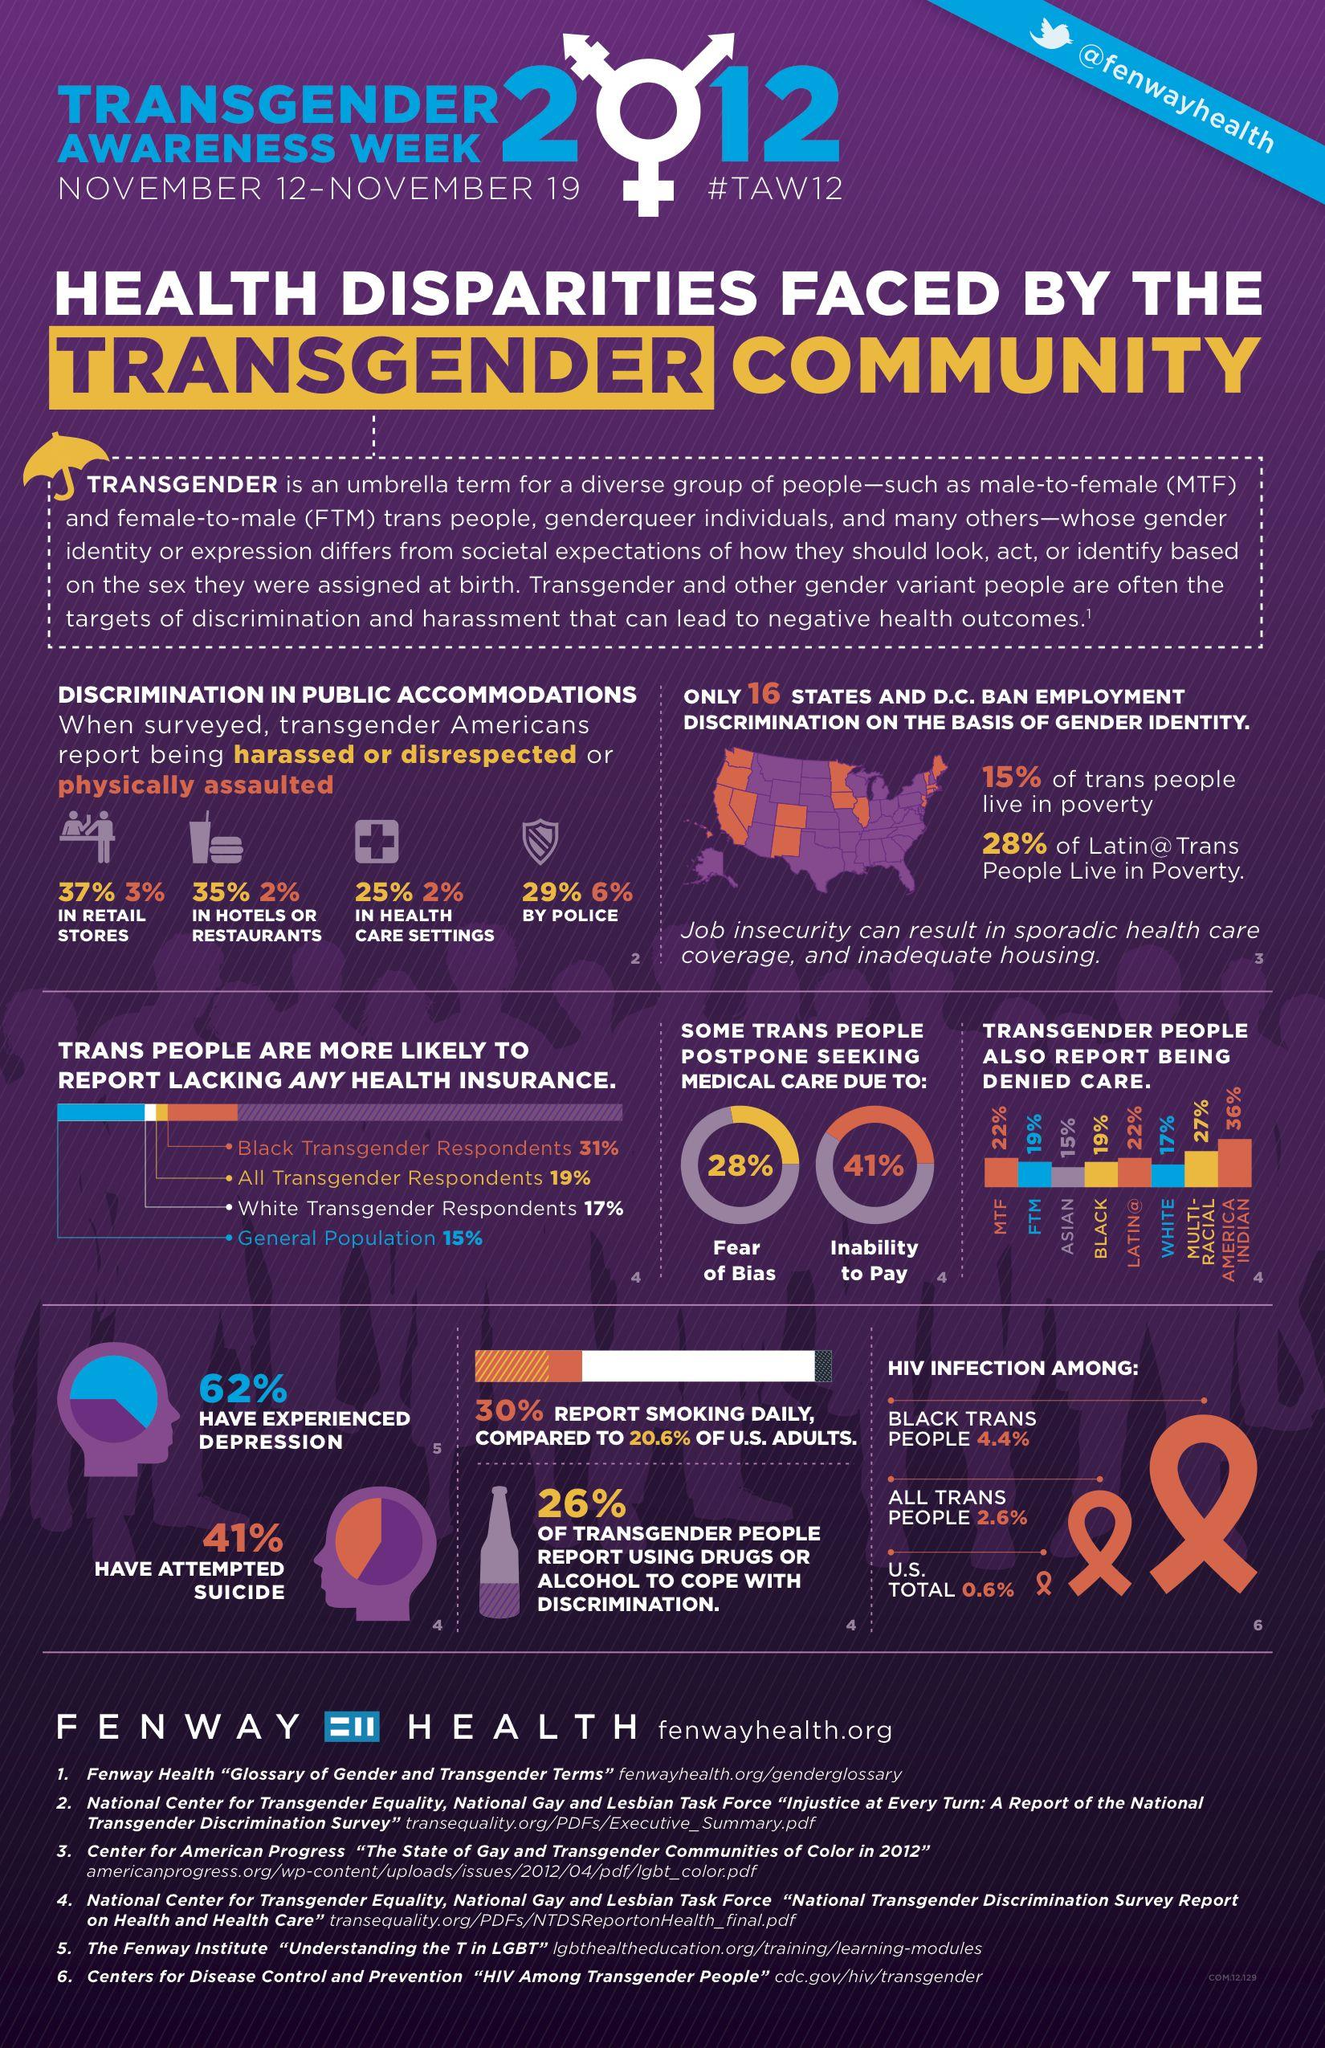Indicate a few pertinent items in this graphic. It is estimated that 28% of transgender individuals postpone medical care due to a fear of bias. According to a survey of 26% of transgenders, drugs or alcohol were commonly used as a coping mechanism to deal with bias and discrimination. According to a report by transgender individuals, 6% have experienced physical assault by police. According to a report by 35% of transgenders who have experienced harassment or disrespect in hotels or restaurants, this behavior is prevalent in these settings. According to a survey, 41% of transgender individuals delay seeking medical care due to financial constraints. 